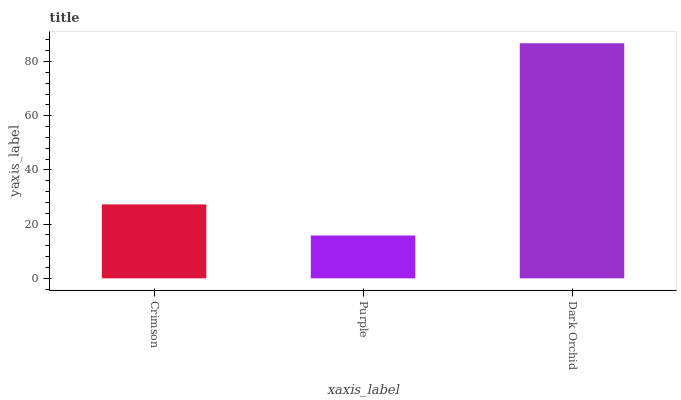Is Dark Orchid the minimum?
Answer yes or no. No. Is Purple the maximum?
Answer yes or no. No. Is Dark Orchid greater than Purple?
Answer yes or no. Yes. Is Purple less than Dark Orchid?
Answer yes or no. Yes. Is Purple greater than Dark Orchid?
Answer yes or no. No. Is Dark Orchid less than Purple?
Answer yes or no. No. Is Crimson the high median?
Answer yes or no. Yes. Is Crimson the low median?
Answer yes or no. Yes. Is Purple the high median?
Answer yes or no. No. Is Dark Orchid the low median?
Answer yes or no. No. 